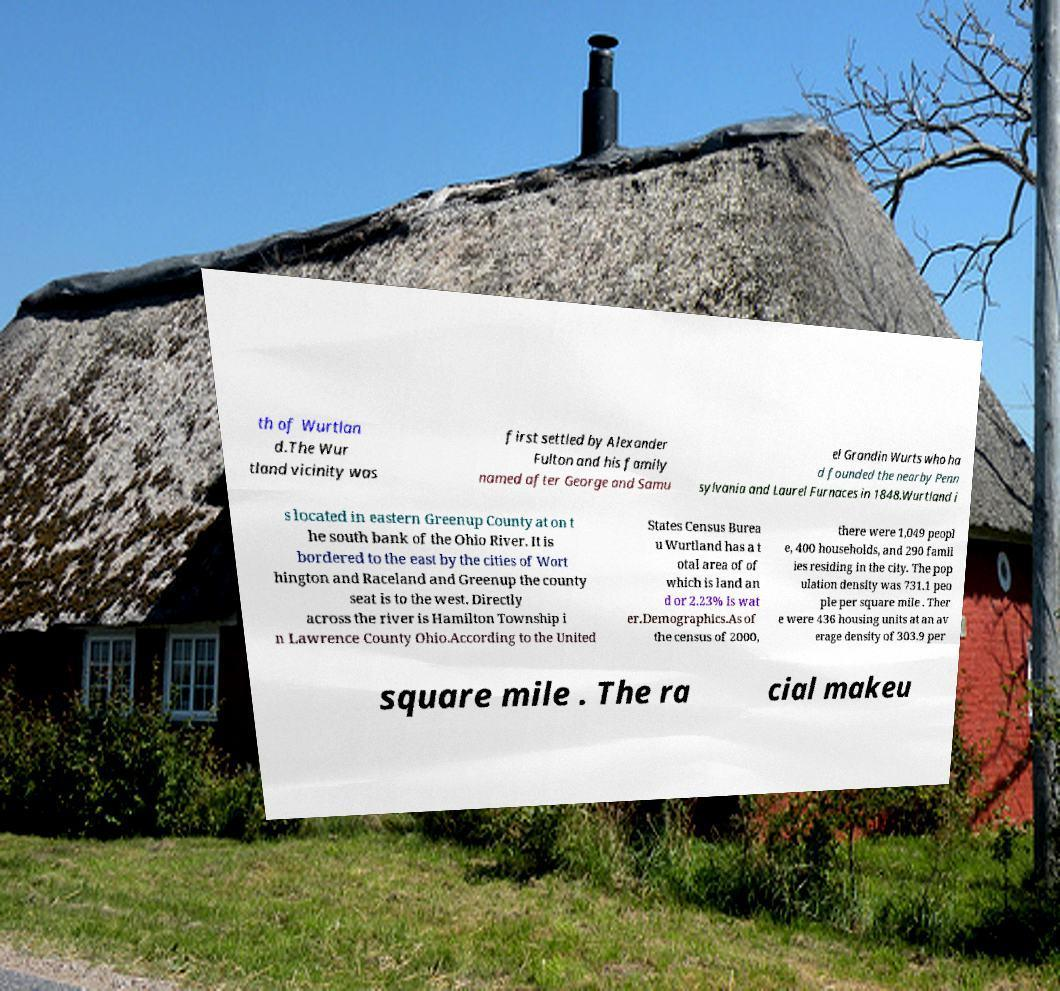Could you extract and type out the text from this image? th of Wurtlan d.The Wur tland vicinity was first settled by Alexander Fulton and his family named after George and Samu el Grandin Wurts who ha d founded the nearby Penn sylvania and Laurel Furnaces in 1848.Wurtland i s located in eastern Greenup County at on t he south bank of the Ohio River. It is bordered to the east by the cities of Wort hington and Raceland and Greenup the county seat is to the west. Directly across the river is Hamilton Township i n Lawrence County Ohio.According to the United States Census Burea u Wurtland has a t otal area of of which is land an d or 2.23% is wat er.Demographics.As of the census of 2000, there were 1,049 peopl e, 400 households, and 290 famil ies residing in the city. The pop ulation density was 731.1 peo ple per square mile . Ther e were 436 housing units at an av erage density of 303.9 per square mile . The ra cial makeu 